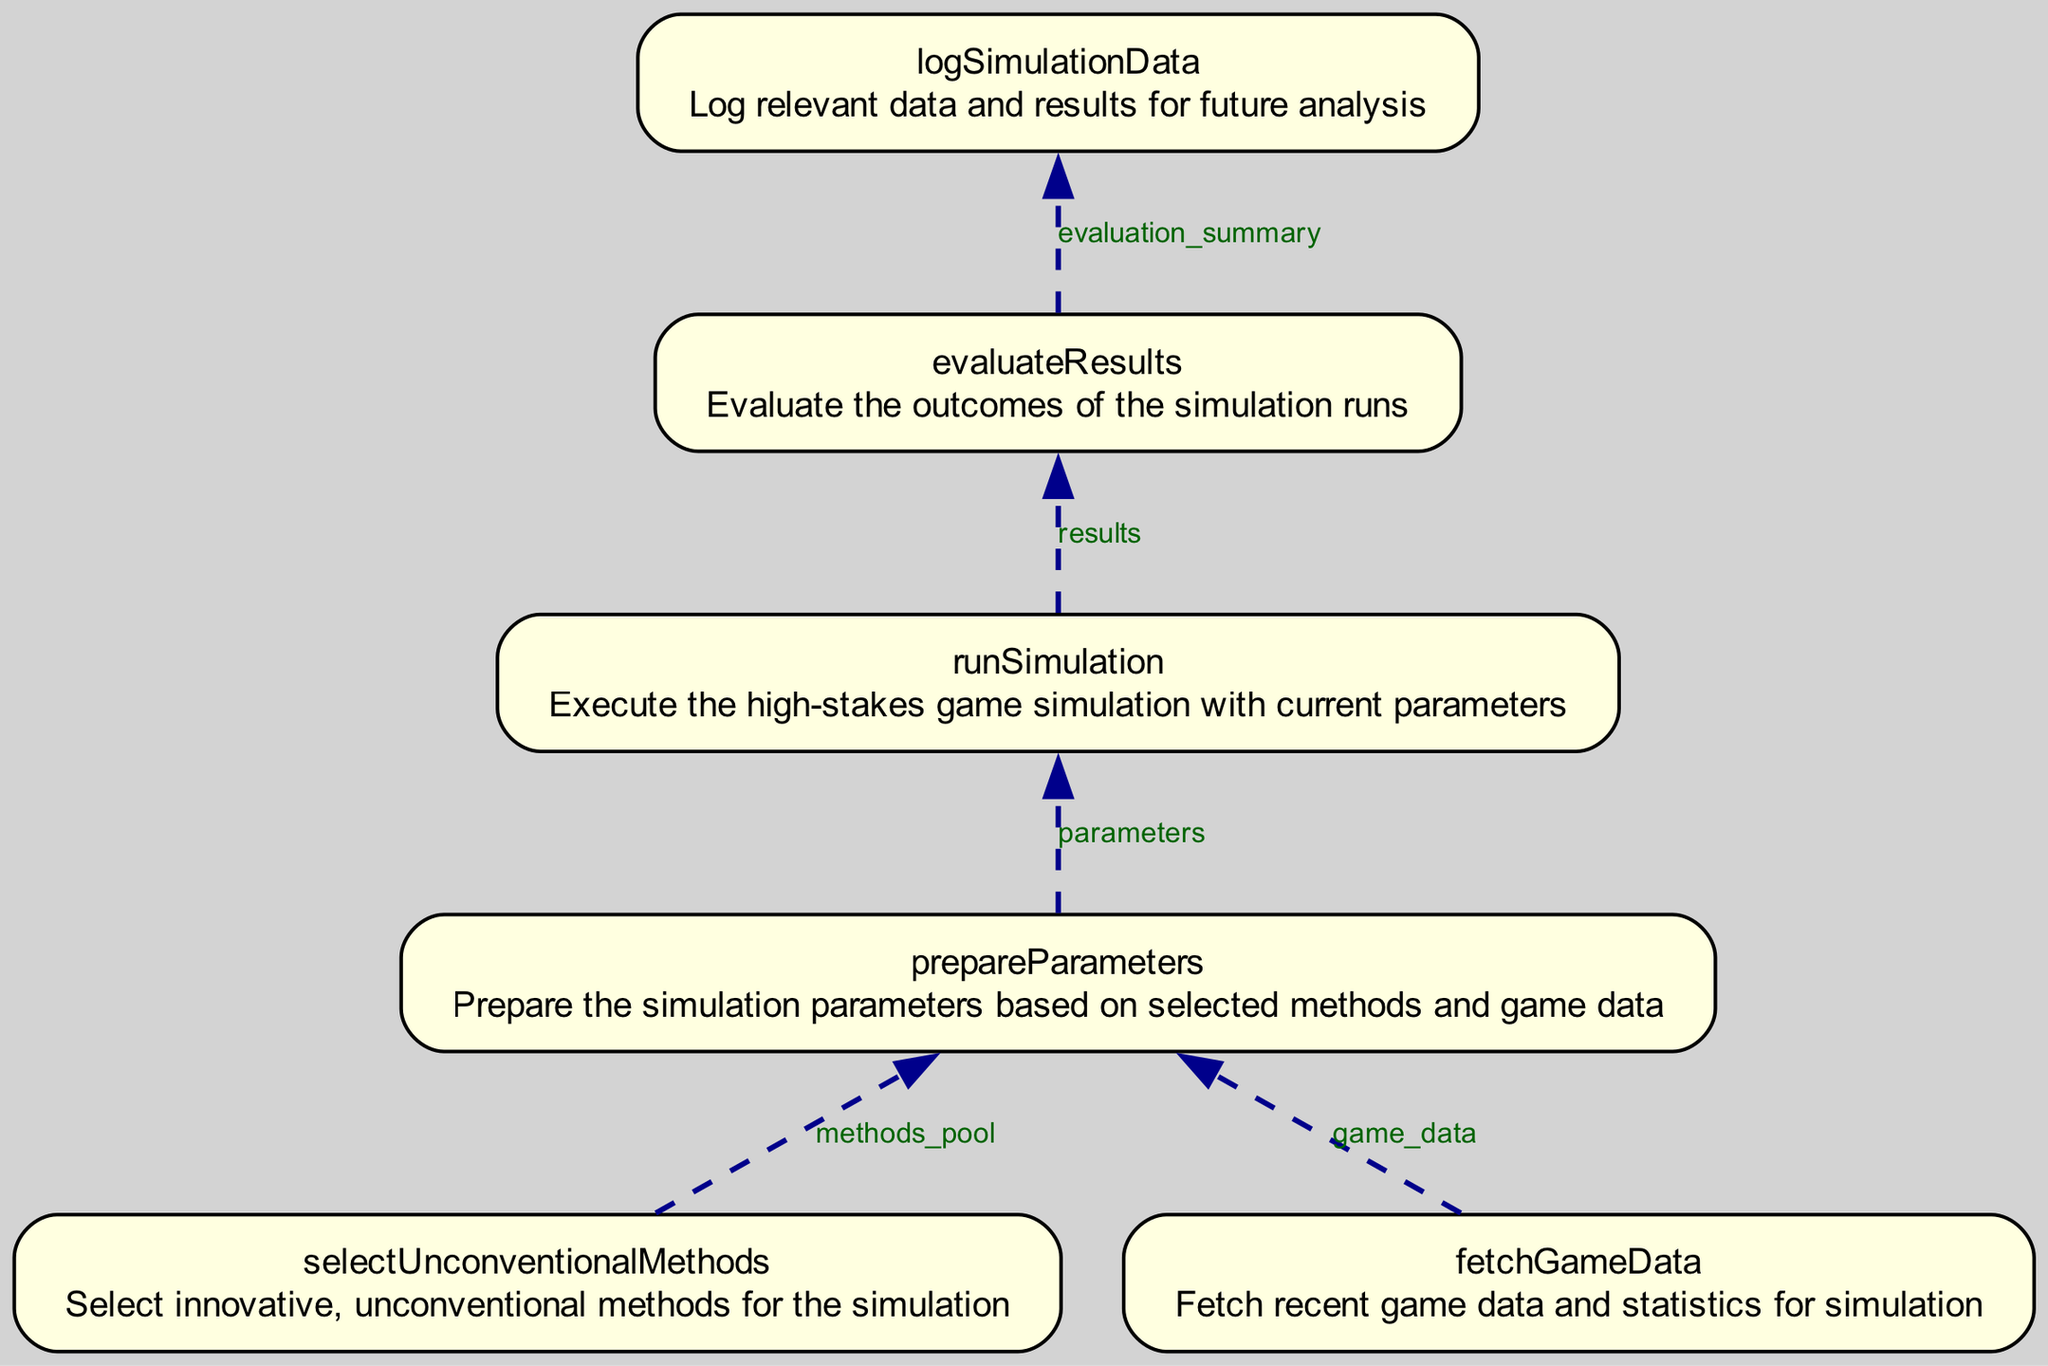What is the first step in the flowchart? The first step, located at the bottom of the flowchart, is "fetchGameData", which involves fetching recent game data and statistics for simulation.
Answer: fetchGameData How many outputs does the "runSimulation" node have? The "runSimulation" node outputs one item, labeled as "results", which is the only output associated with that node.
Answer: 1 What does the "prepareParameters" node use as inputs? The "prepareParameters" node takes two inputs: "methods_pool" and "game_data". These are necessary for preparing the simulation parameters.
Answer: methods_pool and game_data How many total nodes are present in the flowchart? The flowchart contains six nodes, each representing a distinct function or process in the simulation flow, from fetching game data to evaluating results.
Answer: 6 Which node immediately follows "logSimulationData" in the flowchart? The node that immediately follows "logSimulationData" is "evaluateResults", as it is the next step in processing after logging the simulation data.
Answer: evaluateResults What is the output of the "selectUnconventionalMethods" node? The output of the "selectUnconventionalMethods" node is "methods_pool", which contains the selected innovative methods for the simulation.
Answer: methods_pool What type of relationship exists between "fetchGameData" and "runSimulation"? The relationship is a direct flow; "fetchGameData" provides the input data required for the "prepareParameters" node, which is a prerequisite for "runSimulation".
Answer: Direct flow Which two nodes produce outputs used as inputs by the "logSimulationData" node? The two nodes are "evaluateResults" and "runSimulation". "evaluateResults" provides the evaluation summary, while "runSimulation" provides the results needed to log simulation data.
Answer: evaluateResults and runSimulation How do the outputs of "prepareParameters" influence the next node? The outputs of "prepareParameters", which are the "parameters", directly influence the "runSimulation" node as they serve as the input parameters for executing the simulation.
Answer: They are inputs for runSimulation 